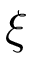Convert formula to latex. <formula><loc_0><loc_0><loc_500><loc_500>\xi</formula> 